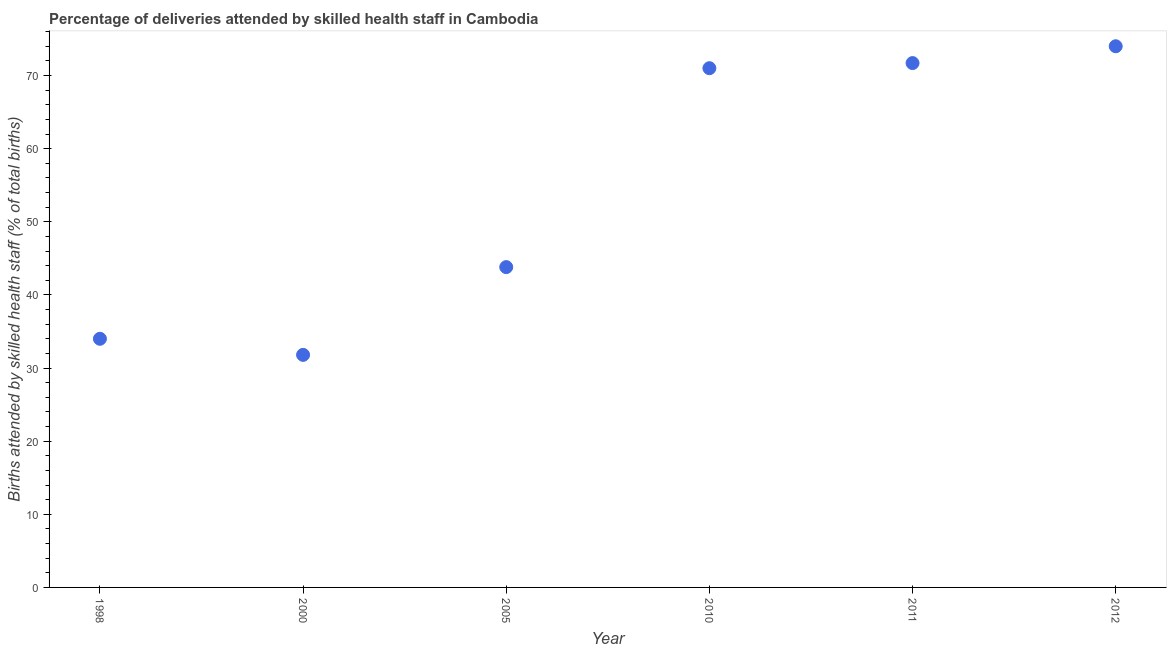What is the number of births attended by skilled health staff in 2005?
Ensure brevity in your answer.  43.8. Across all years, what is the maximum number of births attended by skilled health staff?
Ensure brevity in your answer.  74. Across all years, what is the minimum number of births attended by skilled health staff?
Offer a terse response. 31.8. In which year was the number of births attended by skilled health staff minimum?
Your response must be concise. 2000. What is the sum of the number of births attended by skilled health staff?
Keep it short and to the point. 326.3. What is the difference between the number of births attended by skilled health staff in 2011 and 2012?
Your answer should be very brief. -2.3. What is the average number of births attended by skilled health staff per year?
Offer a terse response. 54.38. What is the median number of births attended by skilled health staff?
Keep it short and to the point. 57.4. Do a majority of the years between 2000 and 2012 (inclusive) have number of births attended by skilled health staff greater than 32 %?
Make the answer very short. Yes. What is the ratio of the number of births attended by skilled health staff in 1998 to that in 2005?
Provide a short and direct response. 0.78. What is the difference between the highest and the second highest number of births attended by skilled health staff?
Offer a very short reply. 2.3. Is the sum of the number of births attended by skilled health staff in 1998 and 2010 greater than the maximum number of births attended by skilled health staff across all years?
Keep it short and to the point. Yes. What is the difference between the highest and the lowest number of births attended by skilled health staff?
Offer a very short reply. 42.2. Are the values on the major ticks of Y-axis written in scientific E-notation?
Your response must be concise. No. What is the title of the graph?
Offer a terse response. Percentage of deliveries attended by skilled health staff in Cambodia. What is the label or title of the Y-axis?
Your answer should be very brief. Births attended by skilled health staff (% of total births). What is the Births attended by skilled health staff (% of total births) in 2000?
Make the answer very short. 31.8. What is the Births attended by skilled health staff (% of total births) in 2005?
Your response must be concise. 43.8. What is the Births attended by skilled health staff (% of total births) in 2011?
Make the answer very short. 71.7. What is the difference between the Births attended by skilled health staff (% of total births) in 1998 and 2010?
Ensure brevity in your answer.  -37. What is the difference between the Births attended by skilled health staff (% of total births) in 1998 and 2011?
Your answer should be very brief. -37.7. What is the difference between the Births attended by skilled health staff (% of total births) in 1998 and 2012?
Offer a very short reply. -40. What is the difference between the Births attended by skilled health staff (% of total births) in 2000 and 2010?
Offer a very short reply. -39.2. What is the difference between the Births attended by skilled health staff (% of total births) in 2000 and 2011?
Provide a short and direct response. -39.9. What is the difference between the Births attended by skilled health staff (% of total births) in 2000 and 2012?
Ensure brevity in your answer.  -42.2. What is the difference between the Births attended by skilled health staff (% of total births) in 2005 and 2010?
Ensure brevity in your answer.  -27.2. What is the difference between the Births attended by skilled health staff (% of total births) in 2005 and 2011?
Keep it short and to the point. -27.9. What is the difference between the Births attended by skilled health staff (% of total births) in 2005 and 2012?
Keep it short and to the point. -30.2. What is the difference between the Births attended by skilled health staff (% of total births) in 2010 and 2012?
Ensure brevity in your answer.  -3. What is the difference between the Births attended by skilled health staff (% of total births) in 2011 and 2012?
Offer a very short reply. -2.3. What is the ratio of the Births attended by skilled health staff (% of total births) in 1998 to that in 2000?
Provide a short and direct response. 1.07. What is the ratio of the Births attended by skilled health staff (% of total births) in 1998 to that in 2005?
Your response must be concise. 0.78. What is the ratio of the Births attended by skilled health staff (% of total births) in 1998 to that in 2010?
Provide a succinct answer. 0.48. What is the ratio of the Births attended by skilled health staff (% of total births) in 1998 to that in 2011?
Your answer should be very brief. 0.47. What is the ratio of the Births attended by skilled health staff (% of total births) in 1998 to that in 2012?
Offer a very short reply. 0.46. What is the ratio of the Births attended by skilled health staff (% of total births) in 2000 to that in 2005?
Your answer should be very brief. 0.73. What is the ratio of the Births attended by skilled health staff (% of total births) in 2000 to that in 2010?
Your answer should be very brief. 0.45. What is the ratio of the Births attended by skilled health staff (% of total births) in 2000 to that in 2011?
Your answer should be compact. 0.44. What is the ratio of the Births attended by skilled health staff (% of total births) in 2000 to that in 2012?
Provide a short and direct response. 0.43. What is the ratio of the Births attended by skilled health staff (% of total births) in 2005 to that in 2010?
Your response must be concise. 0.62. What is the ratio of the Births attended by skilled health staff (% of total births) in 2005 to that in 2011?
Provide a succinct answer. 0.61. What is the ratio of the Births attended by skilled health staff (% of total births) in 2005 to that in 2012?
Provide a succinct answer. 0.59. What is the ratio of the Births attended by skilled health staff (% of total births) in 2011 to that in 2012?
Provide a succinct answer. 0.97. 